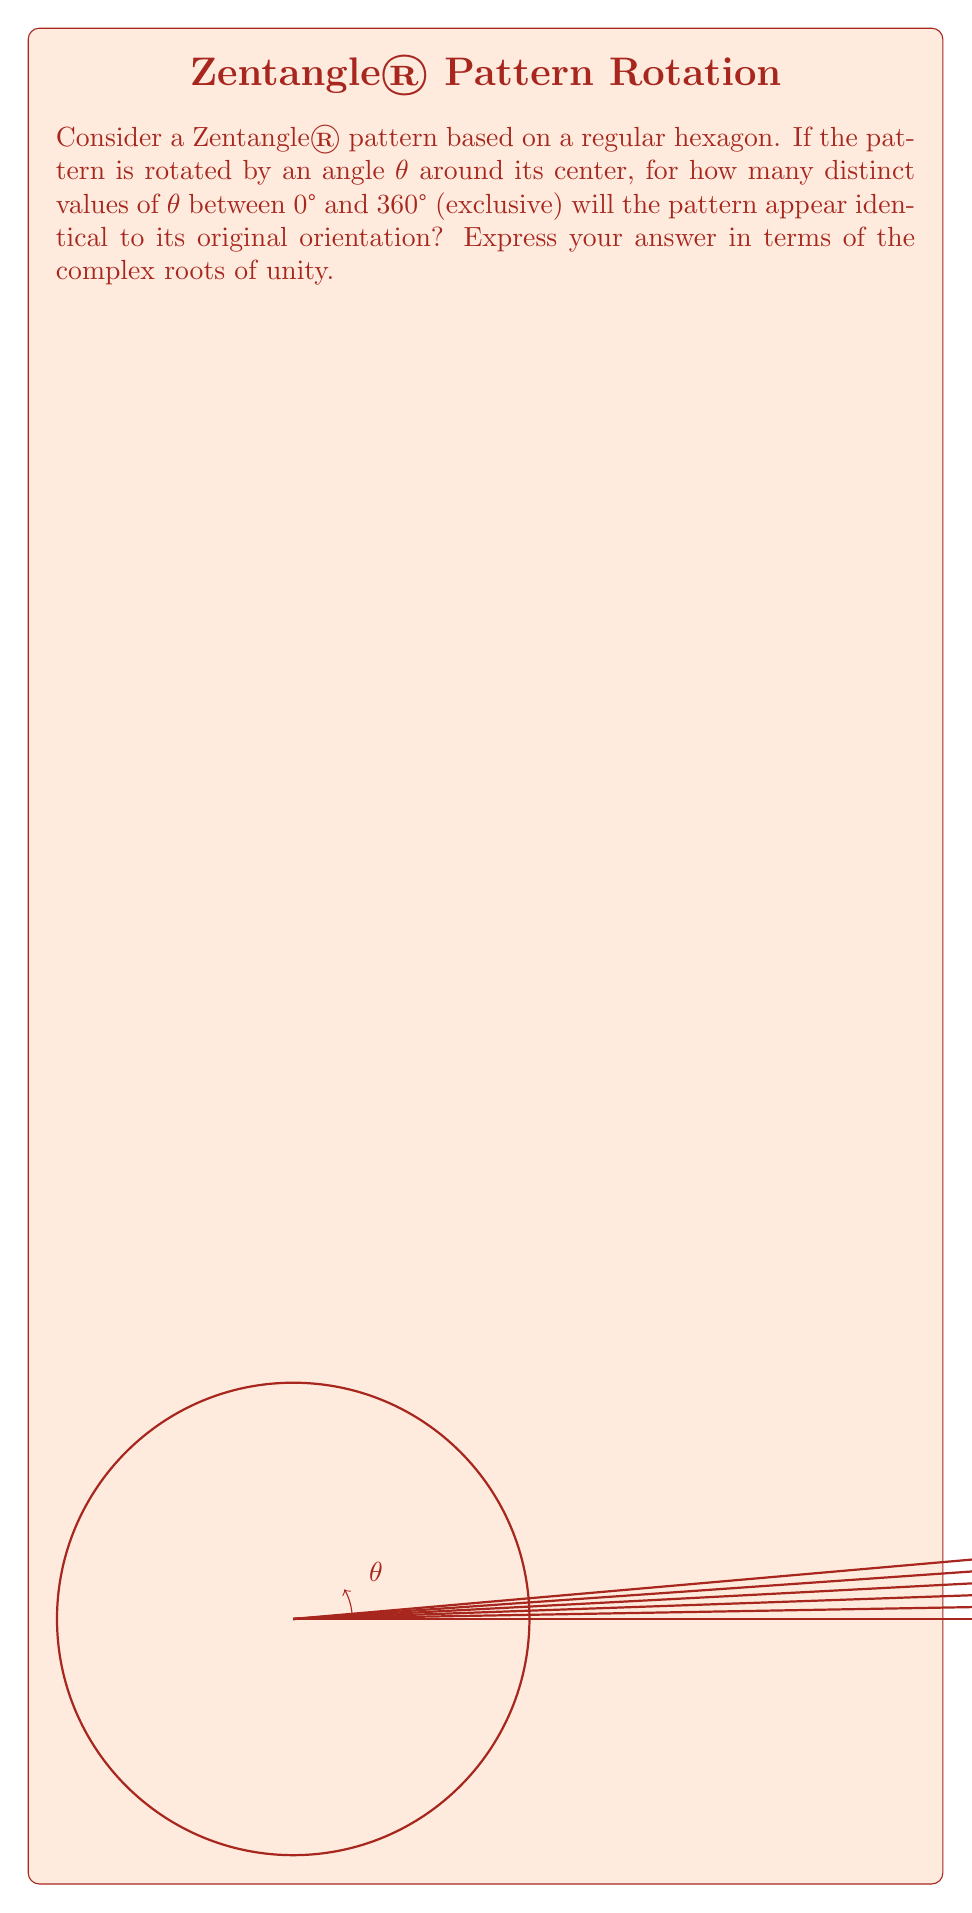What is the answer to this math problem? Let's approach this step-by-step:

1) A regular hexagon has rotational symmetry of order 6. This means it looks the same after rotations of 360°/6 = 60°, 120°, 180°, 240°, 300°, and of course 360° (which is equivalent to 0°).

2) In complex analysis, these rotations can be represented by the 6th roots of unity. The nth roots of unity are given by the formula:

   $$\omega_k = e^{2\pi i k/n}, \quad k = 0, 1, ..., n-1$$

3) For the 6th roots of unity, n = 6, so we have:

   $$\omega_k = e^{2\pi i k/6}, \quad k = 0, 1, 2, 3, 4, 5$$

4) These roots correspond to the following rotations:
   - $\omega_0 = e^{0} = 1$ (0° rotation)
   - $\omega_1 = e^{\pi i/3}$ (60° rotation)
   - $\omega_2 = e^{2\pi i/3}$ (120° rotation)
   - $\omega_3 = e^{\pi i} = -1$ (180° rotation)
   - $\omega_4 = e^{4\pi i/3}$ (240° rotation)
   - $\omega_5 = e^{5\pi i/3}$ (300° rotation)

5) Each of these rotations (except $\omega_0$, which is the identity rotation) will produce a distinct orientation that looks identical to the original pattern.

6) Therefore, there are 5 distinct non-zero rotations (corresponding to $\omega_1$ through $\omega_5$) that will make the pattern appear identical to its original orientation.
Answer: 5 (corresponding to the 5 non-trivial 6th roots of unity) 